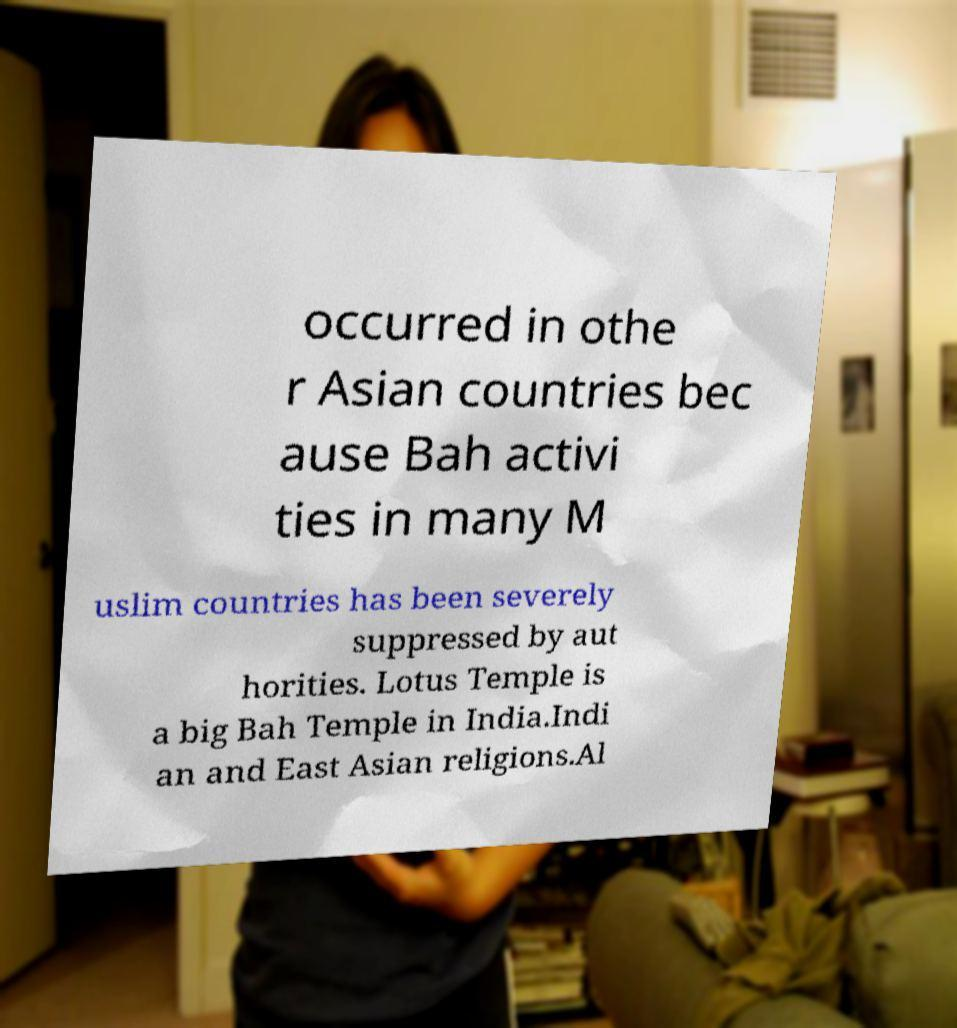What messages or text are displayed in this image? I need them in a readable, typed format. occurred in othe r Asian countries bec ause Bah activi ties in many M uslim countries has been severely suppressed by aut horities. Lotus Temple is a big Bah Temple in India.Indi an and East Asian religions.Al 